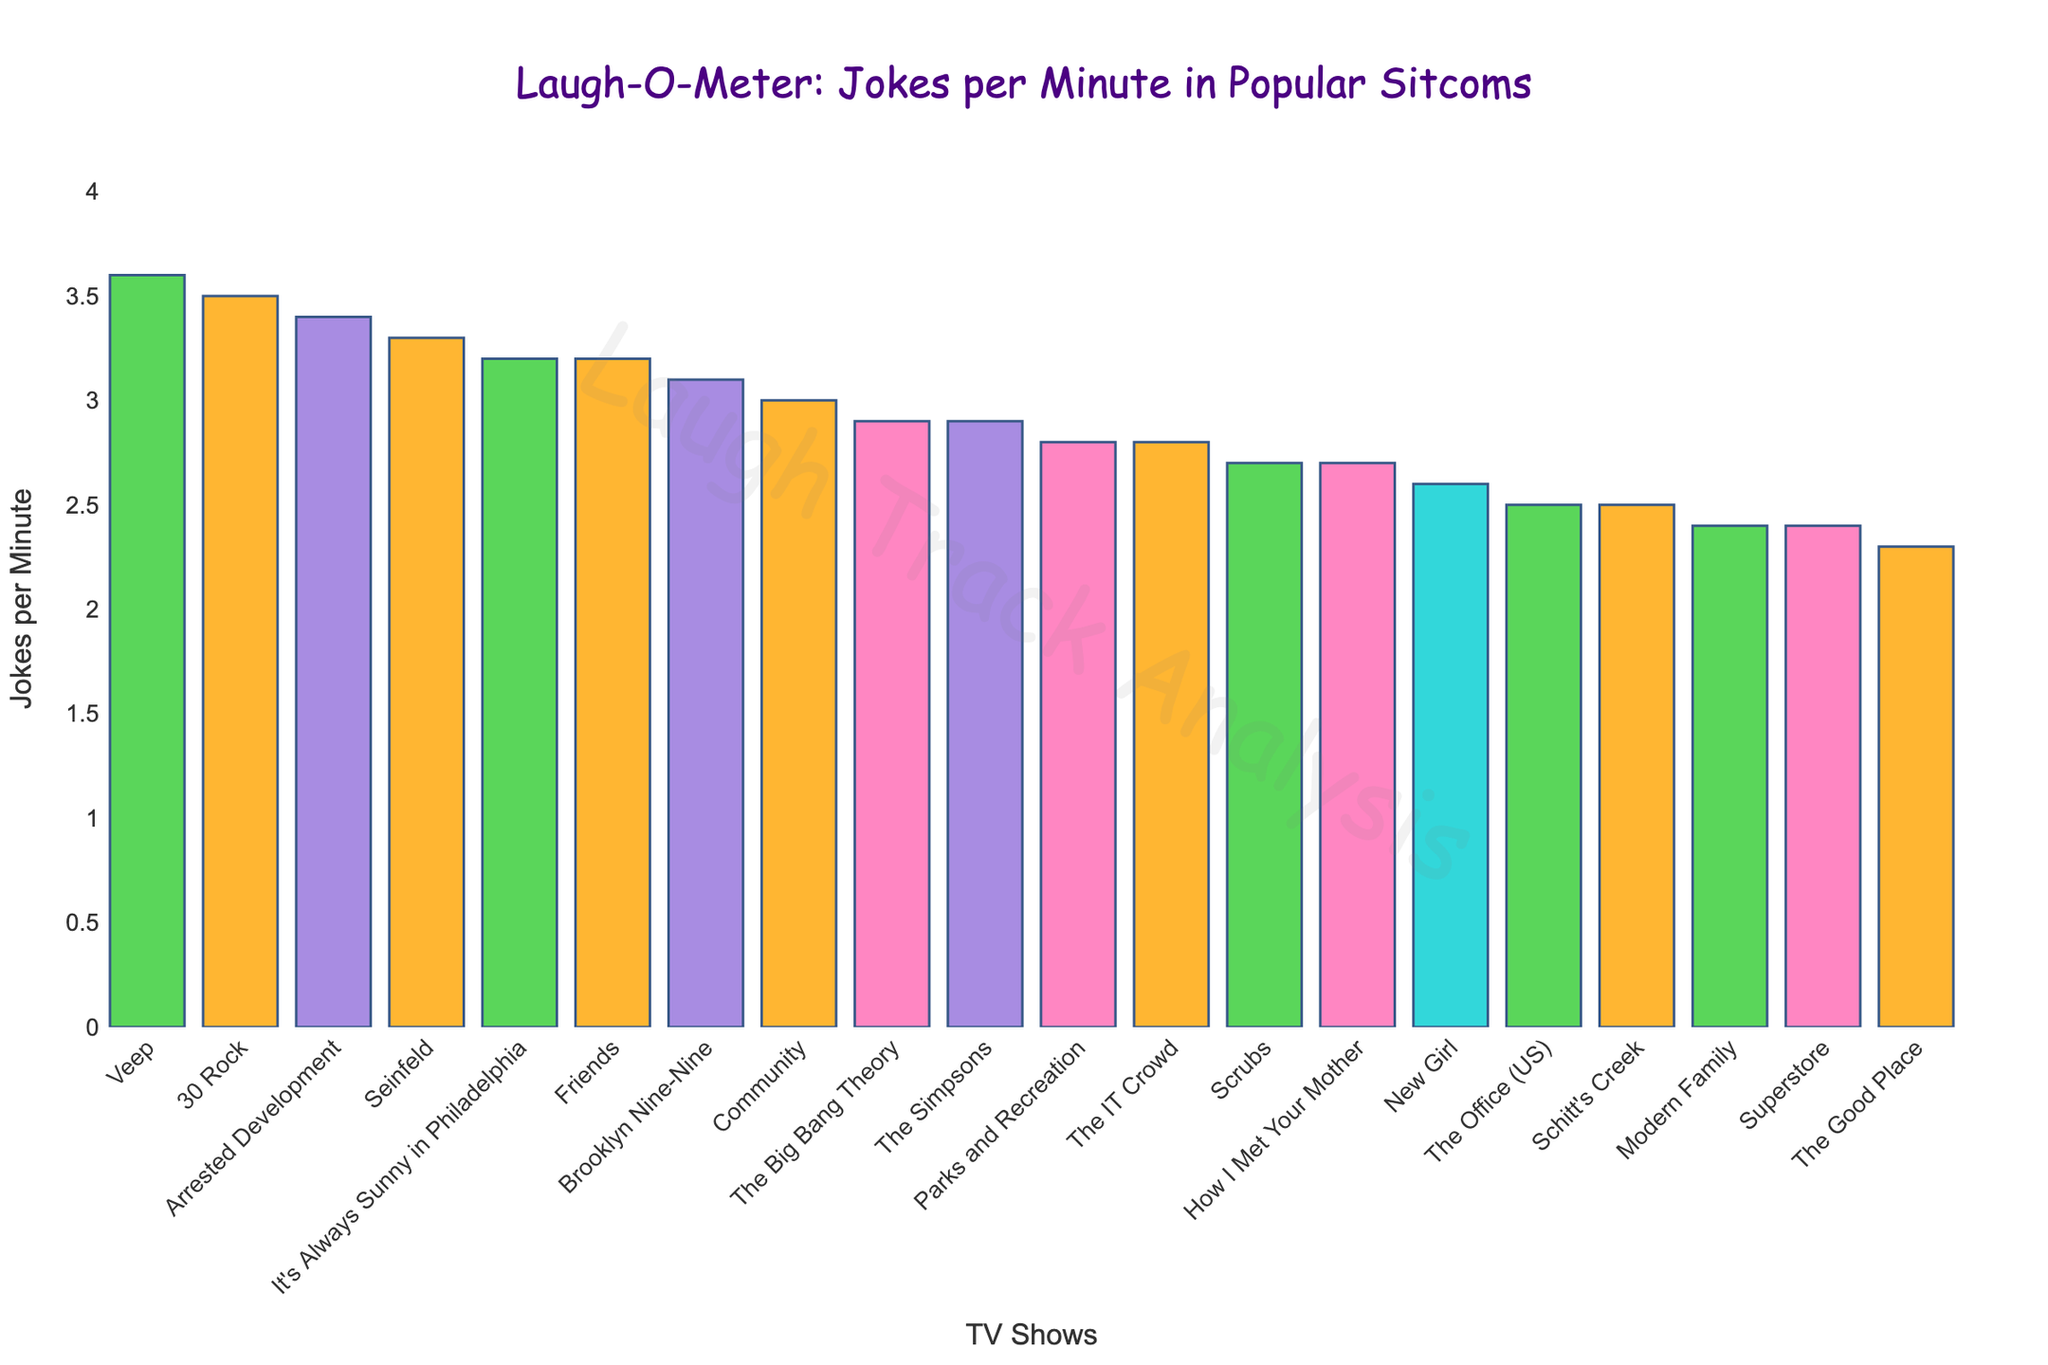Which sitcom has the highest joke frequency per minute? To find the sitcom with the highest joke frequency per minute, look for the tallest bar in the plot. The title of this bar will indicate the show with the most jokes per minute.
Answer: Veep Which sitcoms have a joke frequency that is higher than 3 jokes per minute? Identify all bars that extend above the 3 jokes per minute mark on the y-axis and note the corresponding show names.
Answer: Veep, 30 Rock, Arrested Development, Seinfeld, Friends, It's Always Sunny in Philadelphia, Brooklyn Nine-Nine What's the combined joke frequency per minute for 'Friends' and 'The Office (US)'? Locate the bars corresponding to 'Friends' and 'The Office (US)', read their respective joke frequencies (3.2 for Friends and 2.5 for The Office), and sum them up: 3.2 + 2.5.
Answer: 5.7 Which TV show has a joke frequency per minute less than 2.5 but above 2? Look for bars whose heights fall between the 2 and 2.5 markers on the y-axis and note the corresponding show name.
Answer: The Good Place Out of 'Scrubs', 'Community', and 'The IT Crowd', which has the highest joke frequency per minute? Compare the heights of the bars for 'Scrubs', 'Community', and 'The IT Crowd'. Identify the tallest bar among these three. 'Community' has a joke frequency of 3.0, which is higher than 'Scrubs' (2.7) and 'The IT Crowd' (2.8).
Answer: Community What is the average joke frequency per minute of the shows that have more than 3 jokes per minute? First, identify the shows with more than 3 jokes per minute: Veep (3.6), 30 Rock (3.5), Arrested Development (3.4), Seinfeld (3.3), Friends (3.2), It's Always Sunny in Philadelphia (3.2), Brooklyn Nine-Nine (3.1). Then sum their frequencies (3.6 + 3.5 + 3.4 + 3.3 + 3.2 + 3.2 + 3.1 = 23.3). Divide the sum by the number of shows (7) to find the average: 23.3 / 7.
Answer: 3.33 Which two shows have the closest joke frequency per minute? Compare the heights of all bars and identify the bars whose heights are most similar. Seinfeld has 3.3 and Friends has 3.2, which are closest to each other (difference of 0.1).
Answer: Seinfeld and Friends Between 'The Big Bang Theory' and 'New Girl', which sitcom has more jokes per minute? Compare the heights of the bars for 'The Big Bang Theory' and 'New Girl'. The bar for 'The Big Bang Theory' is higher at 2.9 jokes per minute compared to 'New Girl' at 2.6 jokes per minute.
Answer: The Big Bang Theory Which sitcom is visually marked with blue and what is its joke frequency? Inspect the bar chart colors and find the sitcom whose bar is marked with blue. Use the hover text or legend if available to identify the sitcom and then read the corresponding joke frequency on the y-axis. The sitcom 'The Office (US)' is visually marked with blue and has 2.5 jokes per minute.
Answer: The Office (US) What is the total joke frequency per minute for the top three sitcoms with the highest joke frequencies? Identify the top three sitcoms with the highest joke frequencies, which are Veep (3.6), 30 Rock (3.5), and Arrested Development (3.4). Sum their frequencies: 3.6 + 3.5 + 3.4.
Answer: 10.5 